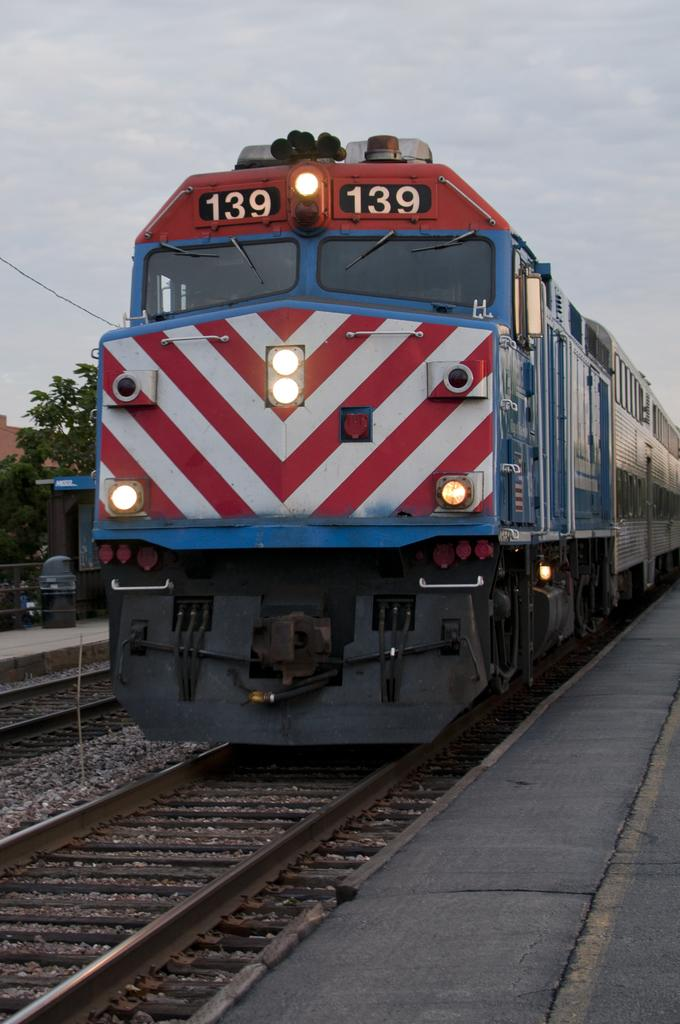What is the main subject in the center of the image? There is a train in the center of the image. What is the train traveling on? The train is traveling on a railway track in the image. What can be seen in the sky in the image? The sky is visible at the top of the image. What type of vegetation is present in the image? There are trees in the image. What advertisement can be seen on the side of the train in the image? There is no advertisement visible on the side of the train in the image. How many times does the train sneeze in the image? Trains do not sneeze, so this question cannot be answered. 